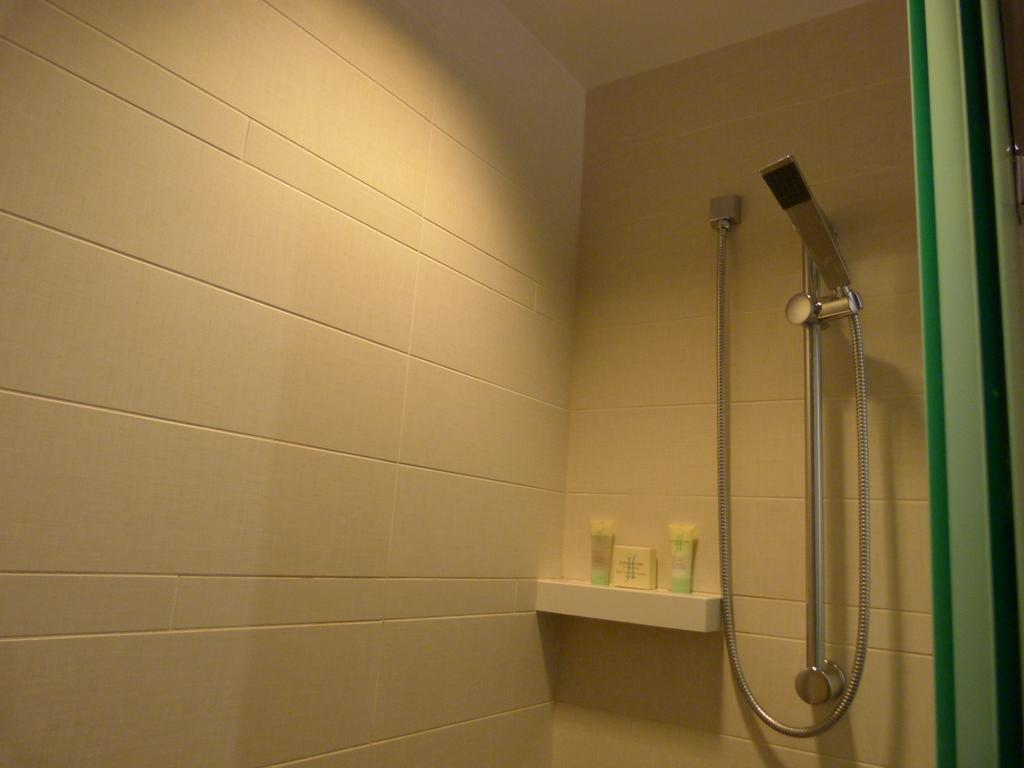What is the main subject of the image? There is a toilet in the image. What else can be seen in the image besides the toilet? There are objects in the image. Are there any objects on the wall in the image? Yes, there are objects on the wall in the image. How many bubbles are floating around the toilet in the image? There are no bubbles present in the image. 